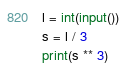Convert code to text. <code><loc_0><loc_0><loc_500><loc_500><_Python_>l = int(input())
s = l / 3
print(s ** 3)</code> 